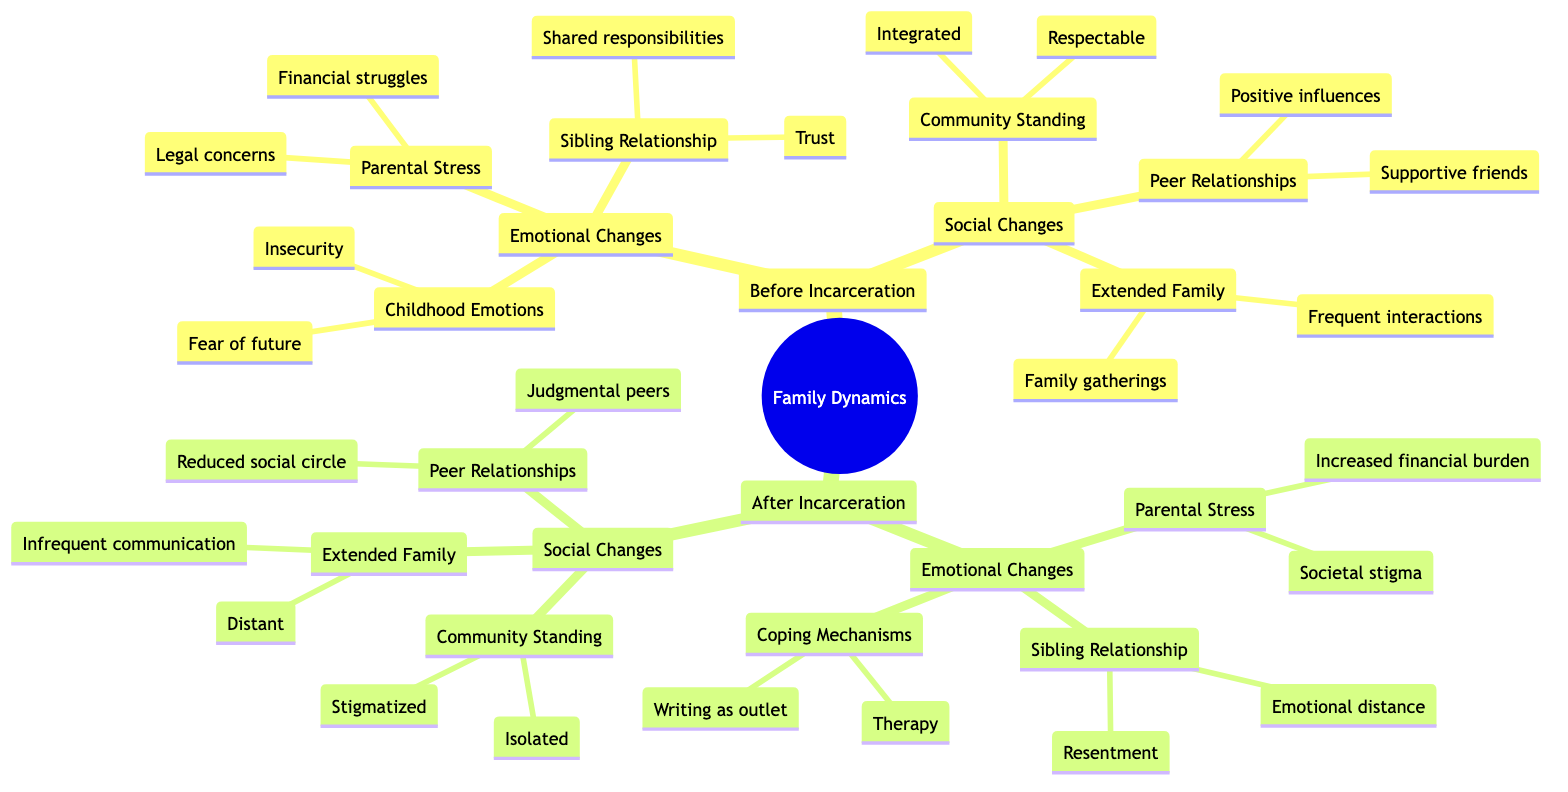What are the three components of emotional changes before incarceration? The diagram lists "Parental Stress," "Sibling Relationship," and "Childhood Emotions" as the three components of emotional changes before incarceration.
Answer: Parental Stress, Sibling Relationship, Childhood Emotions What is the parental stress after incarceration? The diagram states that parental stress after incarceration includes "Increased financial burden" and "Societal stigma." Together, these define the change in parental stress after incarceration.
Answer: Increased financial burden, societal stigma How does the community standing change after incarceration? The diagram indicates that community standing shifts from "Respectable, integrated" before incarceration to "Stigmatized, isolated" after incarceration, highlighting the stark social transition.
Answer: Stigmatized, isolated What is a coping mechanism mentioned after incarceration? The diagram lists "Therapy" and "Writing as outlet" as coping mechanisms used after incarceration, one of which answers the question.
Answer: Therapy How many components are there under social changes before incarceration? The diagram shows three distinct components under social changes: "Community Standing," "Extended Family Dynamics," and "Peer Relationships." Counting these gives the answer.
Answer: 3 What emotional change is marked by resentment after incarceration? The diagram connects "Resentment" in the sibling relationship after incarceration, indicating a shift from trust and shared responsibility before incarceration to emotional distance and resentment after.
Answer: Resentment How do peer relationships change from before to after incarceration? The diagram differentiates peer relationships from before incarceration as "Supportive friends, positive peer influences," whereas after incarceration they shift to "Judgmental peers, reduced social circle," demonstrating a significant change.
Answer: Judgmental peers, reduced social circle What kind of relationship is indicated before incarceration? The sibling relationship before incarceration is characterized by "Trust" and "Shared responsibilities," which signifies a close bond preceding any challenges posed by incarceration.
Answer: Trust, Shared responsibilities 